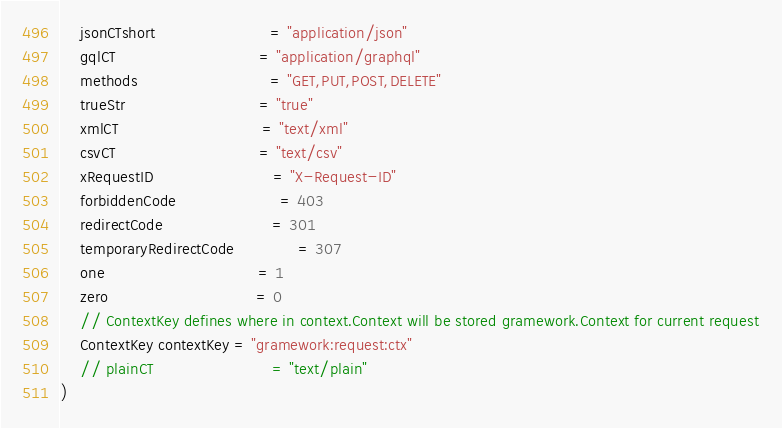Convert code to text. <code><loc_0><loc_0><loc_500><loc_500><_Go_>	jsonCTshort                       = "application/json"
	gqlCT                             = "application/graphql"
	methods                           = "GET,PUT,POST,DELETE"
	trueStr                           = "true"
	xmlCT                             = "text/xml"
	csvCT                             = "text/csv"
	xRequestID                        = "X-Request-ID"
	forbiddenCode                     = 403
	redirectCode                      = 301
	temporaryRedirectCode             = 307
	one                               = 1
	zero                              = 0
	// ContextKey defines where in context.Context will be stored gramework.Context for current request
	ContextKey contextKey = "gramework:request:ctx"
	// plainCT                        = "text/plain"
)
</code> 